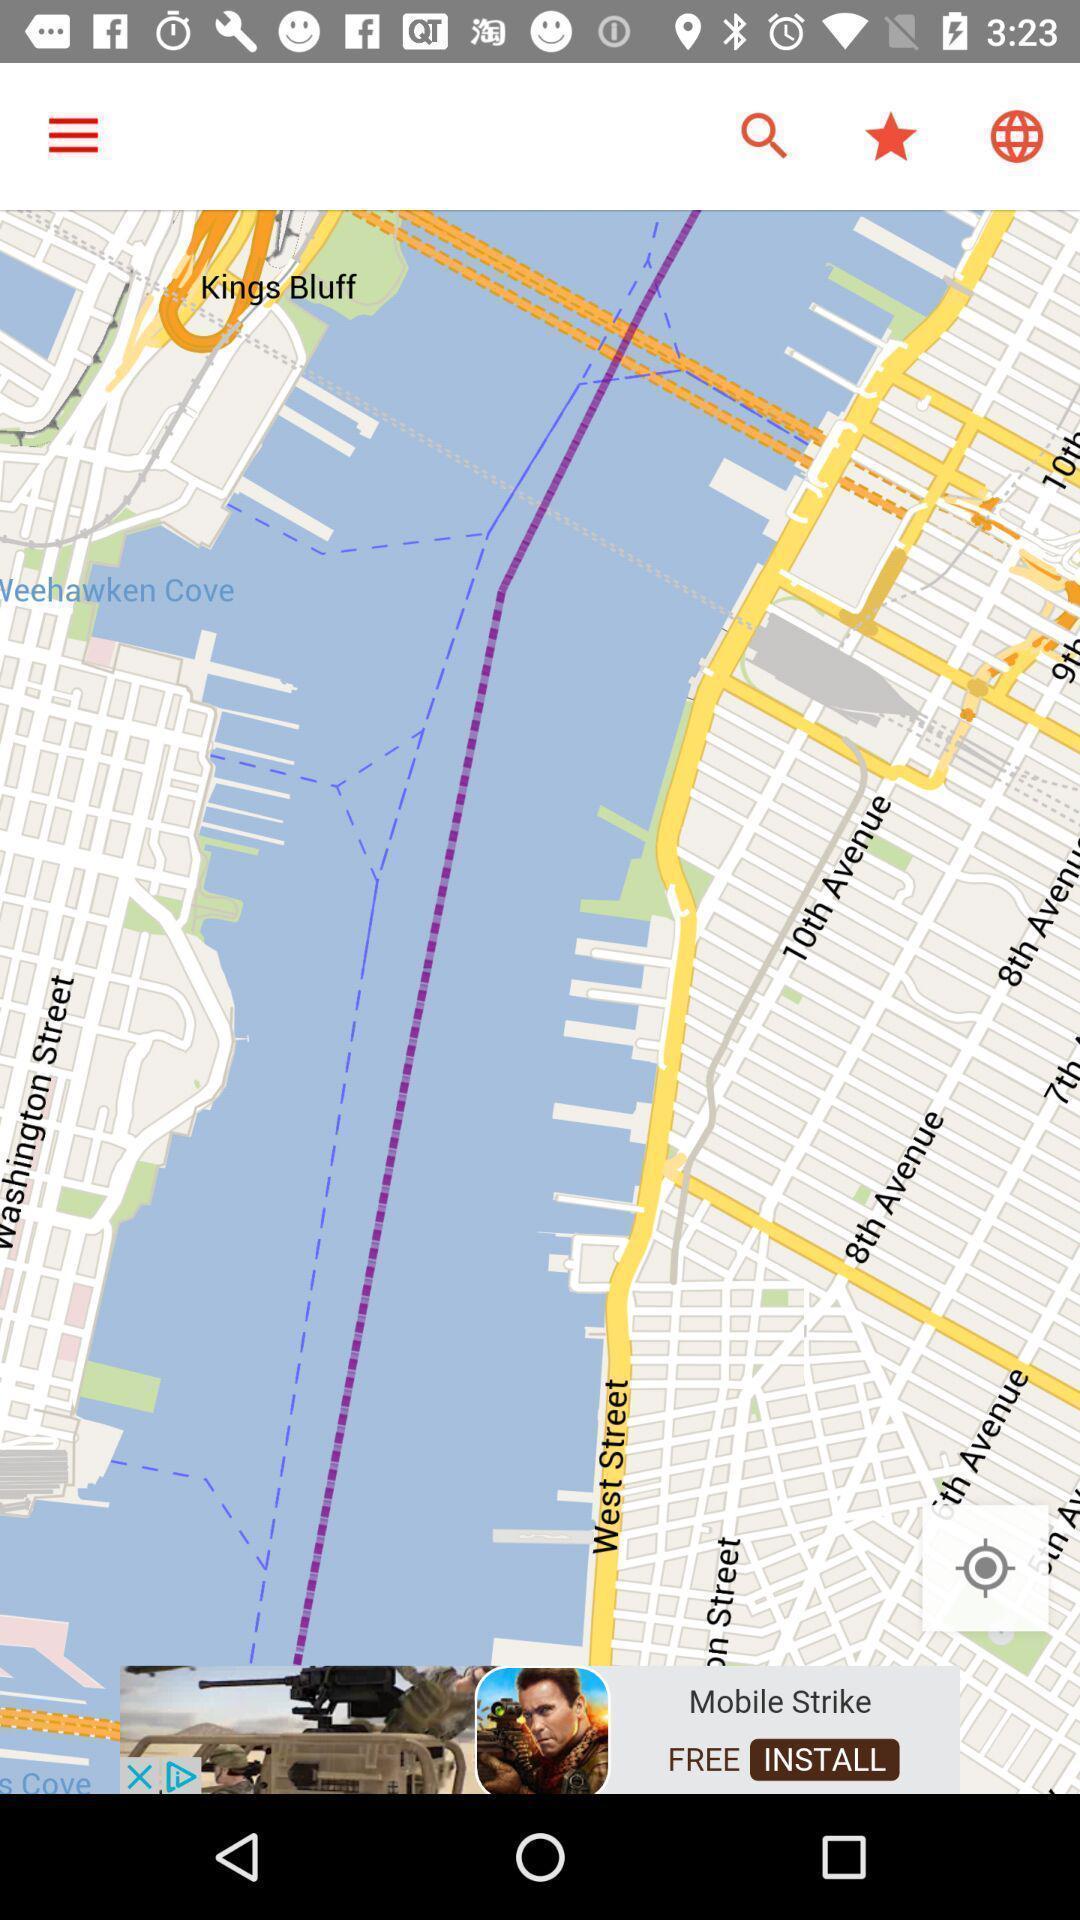Provide a detailed account of this screenshot. Page showing map view on a navigational app. 